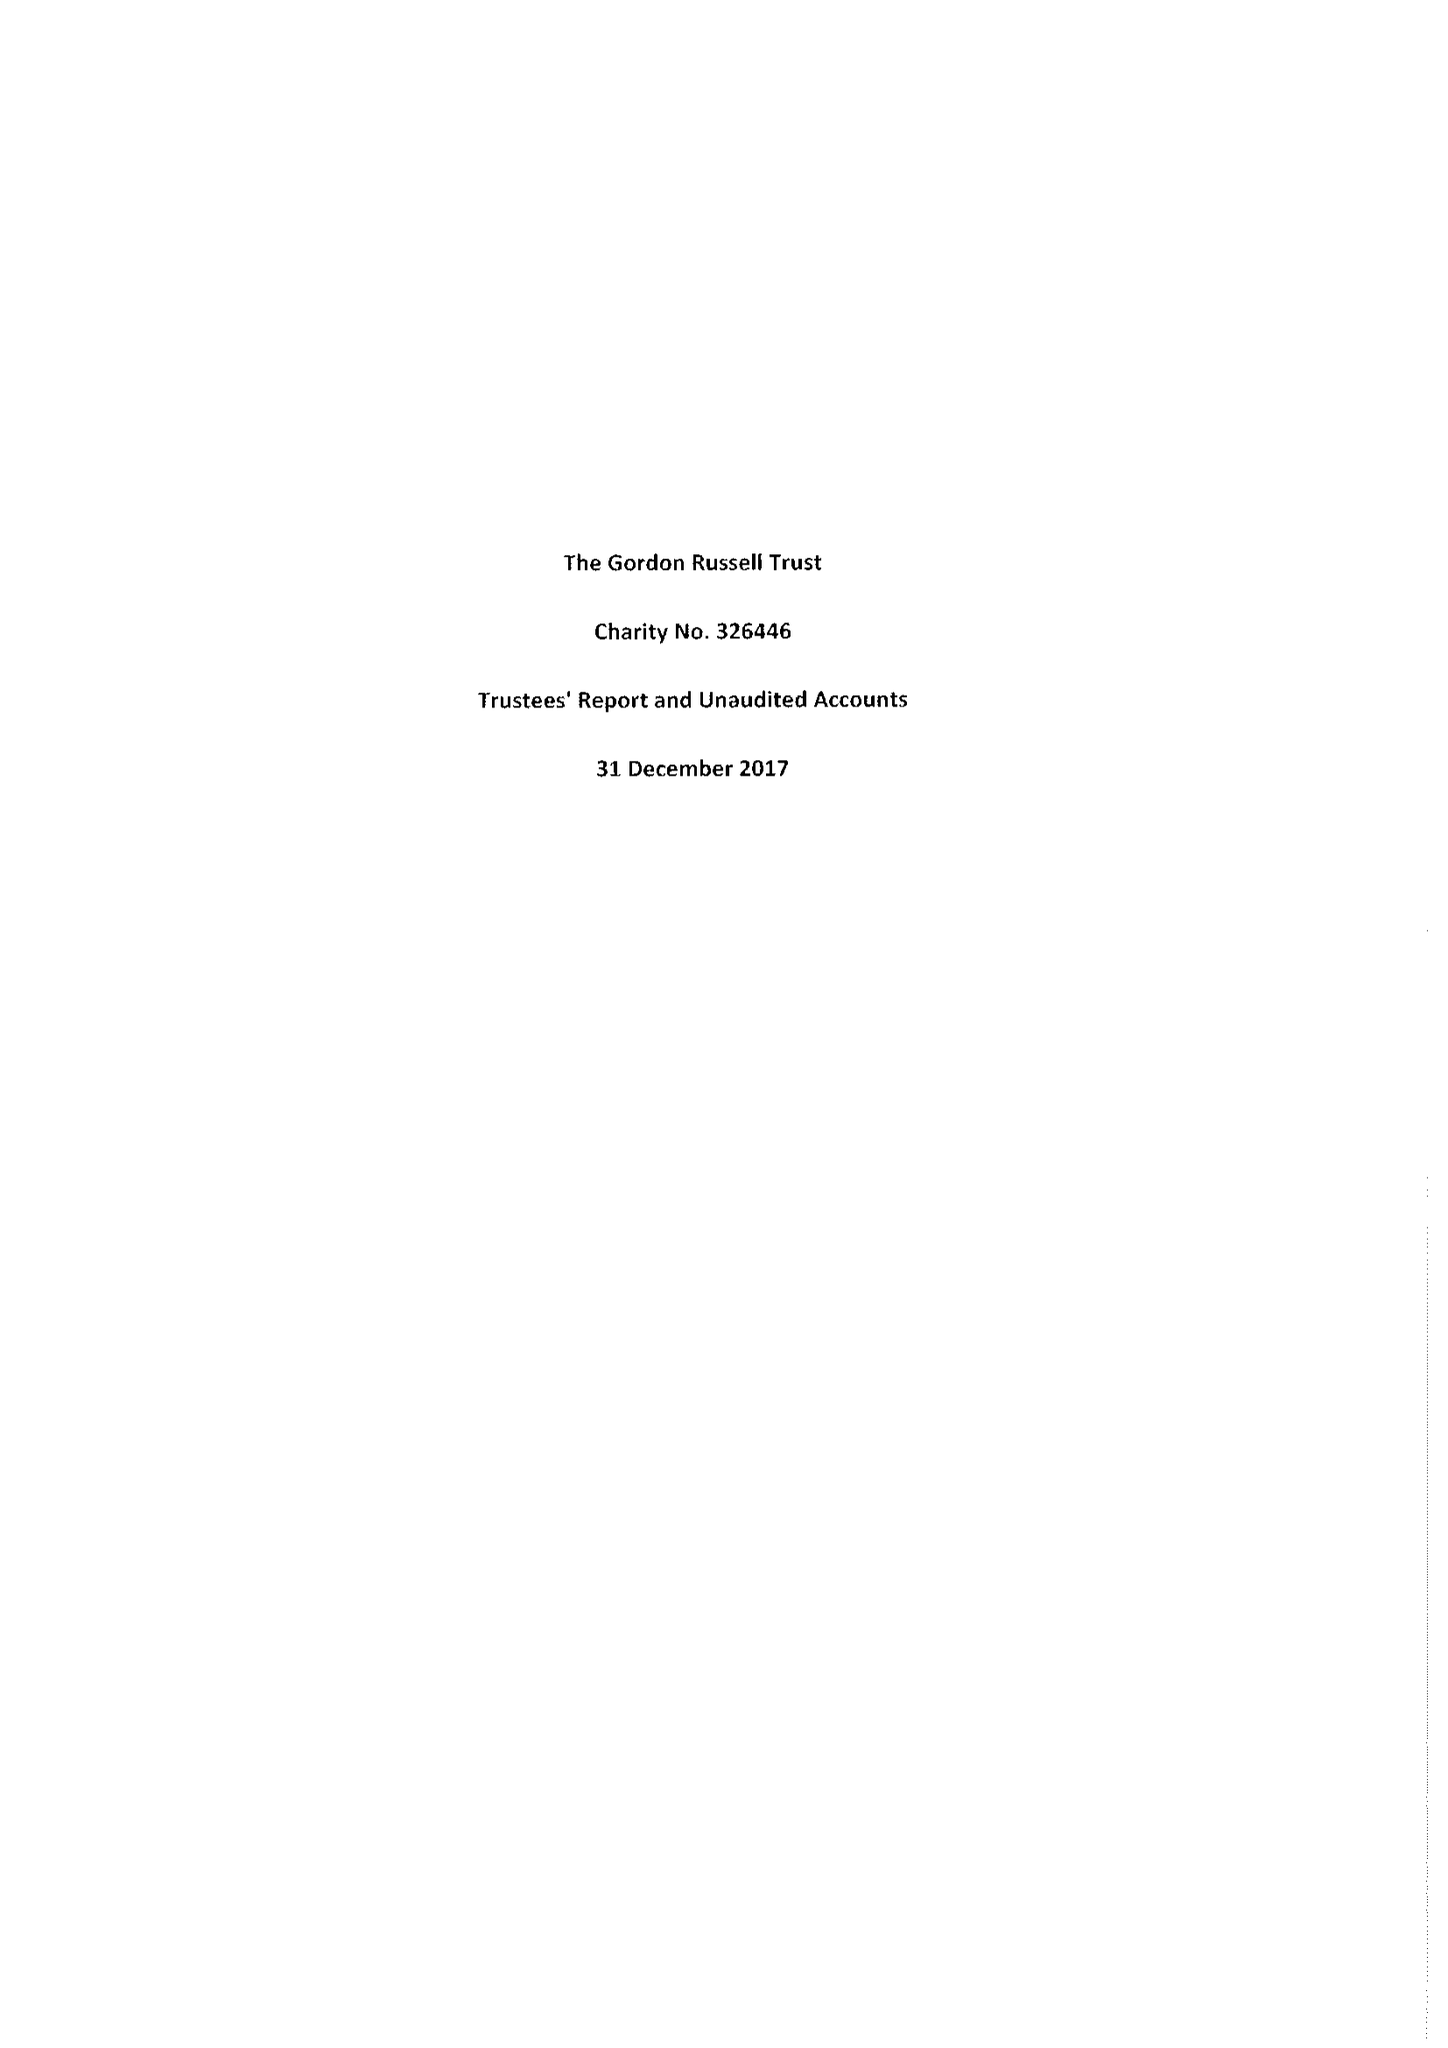What is the value for the address__street_line?
Answer the question using a single word or phrase. 15 RUSSELL SQUARE 